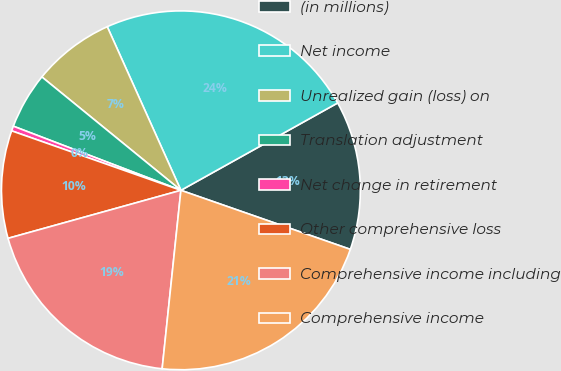<chart> <loc_0><loc_0><loc_500><loc_500><pie_chart><fcel>(in millions)<fcel>Net income<fcel>Unrealized gain (loss) on<fcel>Translation adjustment<fcel>Net change in retirement<fcel>Other comprehensive loss<fcel>Comprehensive income including<fcel>Comprehensive income<nl><fcel>13.43%<fcel>23.64%<fcel>7.38%<fcel>5.07%<fcel>0.44%<fcel>9.69%<fcel>19.02%<fcel>21.33%<nl></chart> 